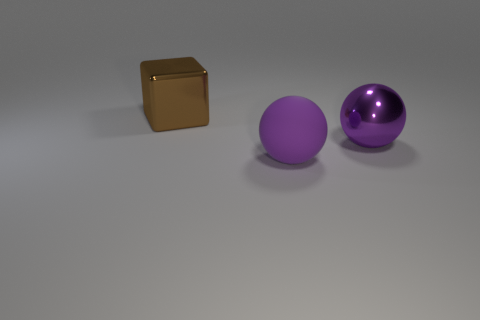Add 2 tiny things. How many objects exist? 5 Subtract all blocks. How many objects are left? 2 Subtract 1 balls. How many balls are left? 1 Subtract all purple objects. Subtract all rubber spheres. How many objects are left? 0 Add 3 large brown shiny things. How many large brown shiny things are left? 4 Add 1 brown rubber spheres. How many brown rubber spheres exist? 1 Subtract 0 brown balls. How many objects are left? 3 Subtract all green cubes. Subtract all green balls. How many cubes are left? 1 